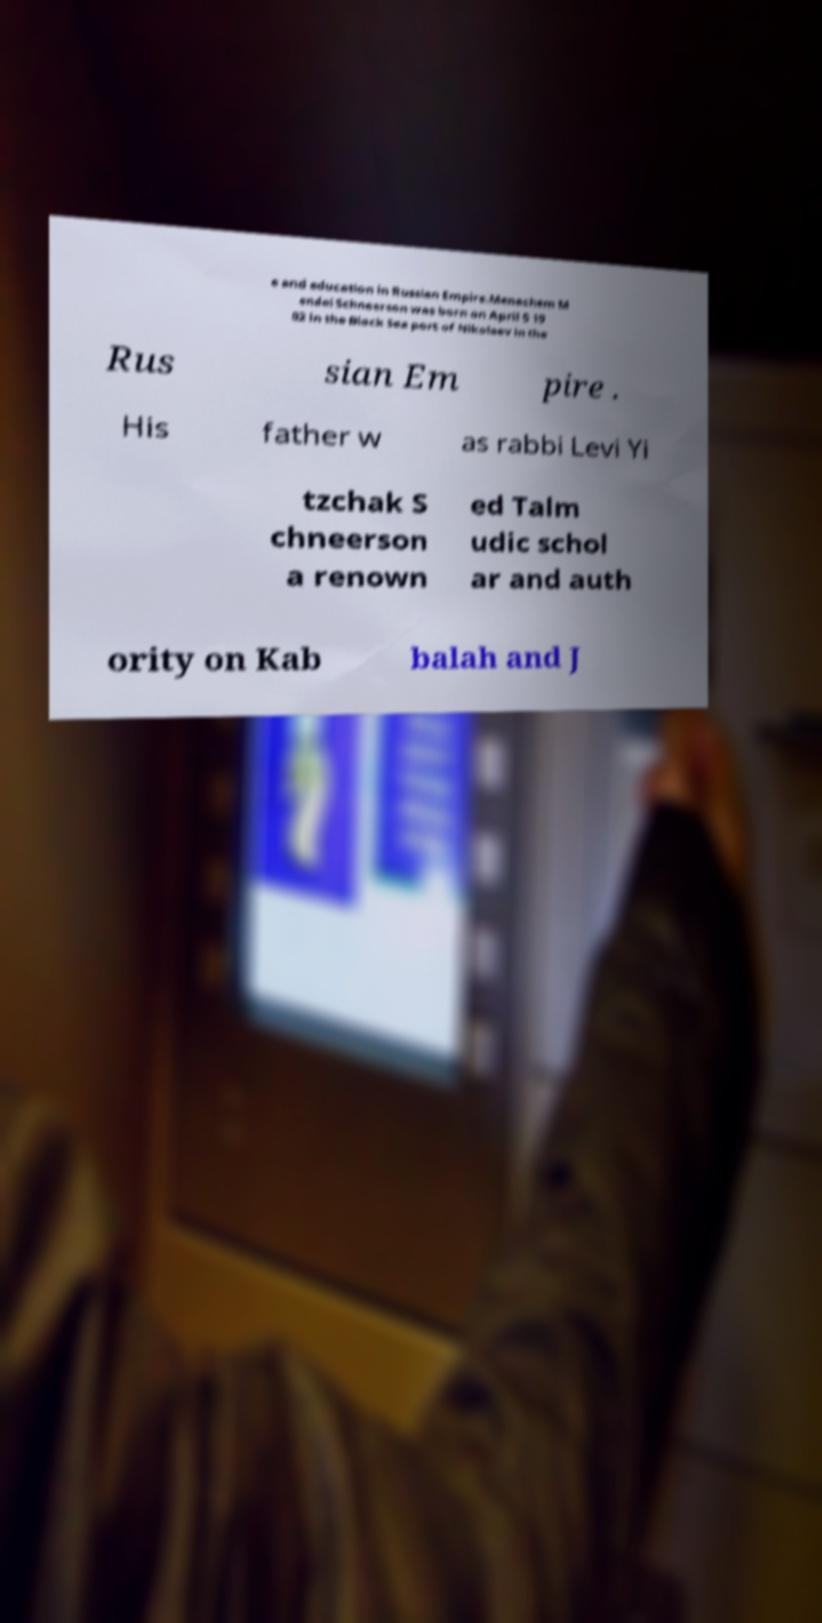Can you read and provide the text displayed in the image?This photo seems to have some interesting text. Can you extract and type it out for me? e and education in Russian Empire.Menachem M endel Schneerson was born on April 5 19 02 in the Black Sea port of Nikolaev in the Rus sian Em pire . His father w as rabbi Levi Yi tzchak S chneerson a renown ed Talm udic schol ar and auth ority on Kab balah and J 